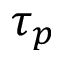Convert formula to latex. <formula><loc_0><loc_0><loc_500><loc_500>\tau _ { p }</formula> 